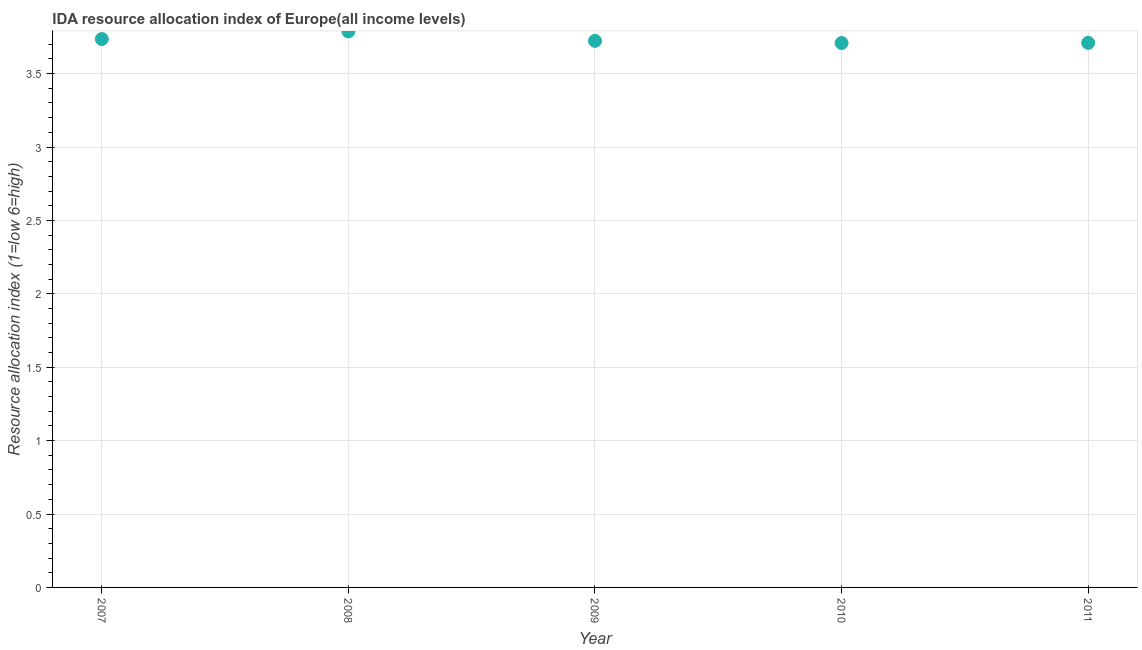What is the ida resource allocation index in 2009?
Provide a succinct answer. 3.72. Across all years, what is the maximum ida resource allocation index?
Provide a succinct answer. 3.79. Across all years, what is the minimum ida resource allocation index?
Keep it short and to the point. 3.71. In which year was the ida resource allocation index maximum?
Provide a succinct answer. 2008. What is the sum of the ida resource allocation index?
Provide a succinct answer. 18.66. What is the difference between the ida resource allocation index in 2007 and 2011?
Provide a short and direct response. 0.03. What is the average ida resource allocation index per year?
Keep it short and to the point. 3.73. What is the median ida resource allocation index?
Ensure brevity in your answer.  3.72. In how many years, is the ida resource allocation index greater than 2.3 ?
Keep it short and to the point. 5. What is the ratio of the ida resource allocation index in 2007 to that in 2010?
Provide a short and direct response. 1.01. Is the ida resource allocation index in 2009 less than that in 2011?
Keep it short and to the point. No. Is the difference between the ida resource allocation index in 2009 and 2010 greater than the difference between any two years?
Your answer should be very brief. No. What is the difference between the highest and the second highest ida resource allocation index?
Provide a short and direct response. 0.05. What is the difference between the highest and the lowest ida resource allocation index?
Give a very brief answer. 0.08. In how many years, is the ida resource allocation index greater than the average ida resource allocation index taken over all years?
Give a very brief answer. 2. Does the ida resource allocation index monotonically increase over the years?
Provide a short and direct response. No. How many dotlines are there?
Ensure brevity in your answer.  1. How many years are there in the graph?
Ensure brevity in your answer.  5. What is the difference between two consecutive major ticks on the Y-axis?
Offer a very short reply. 0.5. Does the graph contain any zero values?
Provide a short and direct response. No. What is the title of the graph?
Your answer should be very brief. IDA resource allocation index of Europe(all income levels). What is the label or title of the X-axis?
Provide a short and direct response. Year. What is the label or title of the Y-axis?
Give a very brief answer. Resource allocation index (1=low 6=high). What is the Resource allocation index (1=low 6=high) in 2007?
Provide a short and direct response. 3.74. What is the Resource allocation index (1=low 6=high) in 2008?
Ensure brevity in your answer.  3.79. What is the Resource allocation index (1=low 6=high) in 2009?
Provide a short and direct response. 3.72. What is the Resource allocation index (1=low 6=high) in 2010?
Offer a terse response. 3.71. What is the Resource allocation index (1=low 6=high) in 2011?
Your answer should be very brief. 3.71. What is the difference between the Resource allocation index (1=low 6=high) in 2007 and 2008?
Your answer should be very brief. -0.05. What is the difference between the Resource allocation index (1=low 6=high) in 2007 and 2009?
Ensure brevity in your answer.  0.01. What is the difference between the Resource allocation index (1=low 6=high) in 2007 and 2010?
Keep it short and to the point. 0.03. What is the difference between the Resource allocation index (1=low 6=high) in 2007 and 2011?
Make the answer very short. 0.03. What is the difference between the Resource allocation index (1=low 6=high) in 2008 and 2009?
Offer a terse response. 0.06. What is the difference between the Resource allocation index (1=low 6=high) in 2008 and 2010?
Make the answer very short. 0.08. What is the difference between the Resource allocation index (1=low 6=high) in 2008 and 2011?
Make the answer very short. 0.08. What is the difference between the Resource allocation index (1=low 6=high) in 2009 and 2010?
Offer a terse response. 0.01. What is the difference between the Resource allocation index (1=low 6=high) in 2009 and 2011?
Give a very brief answer. 0.01. What is the difference between the Resource allocation index (1=low 6=high) in 2010 and 2011?
Provide a succinct answer. -0. What is the ratio of the Resource allocation index (1=low 6=high) in 2007 to that in 2009?
Ensure brevity in your answer.  1. What is the ratio of the Resource allocation index (1=low 6=high) in 2007 to that in 2010?
Your answer should be very brief. 1.01. What is the ratio of the Resource allocation index (1=low 6=high) in 2007 to that in 2011?
Your response must be concise. 1.01. What is the ratio of the Resource allocation index (1=low 6=high) in 2008 to that in 2009?
Make the answer very short. 1.02. What is the ratio of the Resource allocation index (1=low 6=high) in 2008 to that in 2010?
Provide a short and direct response. 1.02. What is the ratio of the Resource allocation index (1=low 6=high) in 2009 to that in 2011?
Keep it short and to the point. 1. 